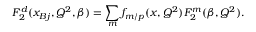<formula> <loc_0><loc_0><loc_500><loc_500>F _ { 2 } ^ { d } ( x _ { B j } , Q ^ { 2 } , \beta ) = \sum _ { m } f _ { m / p } ( x , Q ^ { 2 } ) F _ { 2 } ^ { m } ( \beta , Q ^ { 2 } ) .</formula> 